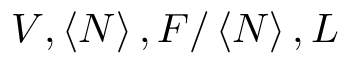Convert formula to latex. <formula><loc_0><loc_0><loc_500><loc_500>V , \left \langle N \right \rangle , F / \left \langle N \right \rangle , L</formula> 